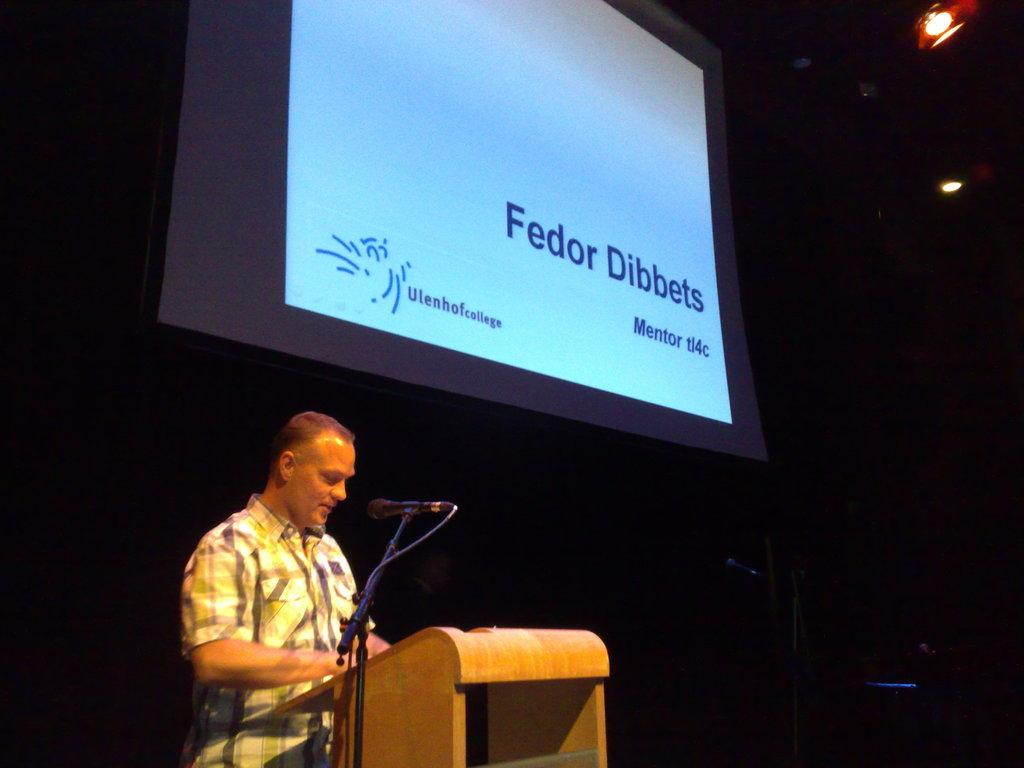What is the man in the image doing? The man is standing at the podium in the image. What is the man likely using to amplify his voice? There is a microphone on a stand in the image, which the man might be using. What can be seen in the background of the image? The background of the image is dark, with a screen and lights visible. What type of flowers are being thrown away in the image? There are no flowers or any indication of waste present in the image. 